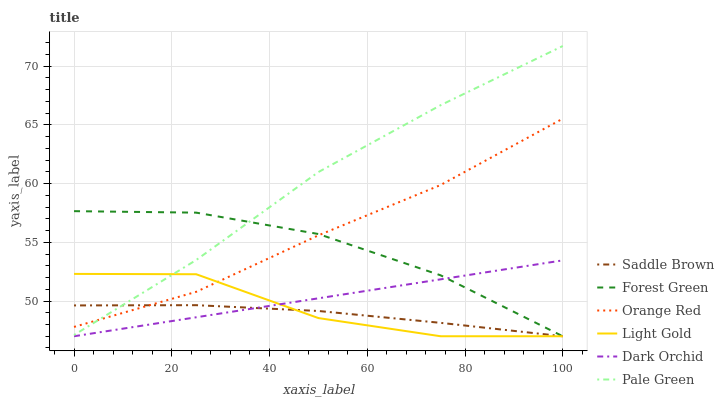Does Saddle Brown have the minimum area under the curve?
Answer yes or no. Yes. Does Pale Green have the maximum area under the curve?
Answer yes or no. Yes. Does Orange Red have the minimum area under the curve?
Answer yes or no. No. Does Orange Red have the maximum area under the curve?
Answer yes or no. No. Is Dark Orchid the smoothest?
Answer yes or no. Yes. Is Light Gold the roughest?
Answer yes or no. Yes. Is Orange Red the smoothest?
Answer yes or no. No. Is Orange Red the roughest?
Answer yes or no. No. Does Dark Orchid have the lowest value?
Answer yes or no. Yes. Does Orange Red have the lowest value?
Answer yes or no. No. Does Pale Green have the highest value?
Answer yes or no. Yes. Does Orange Red have the highest value?
Answer yes or no. No. Is Dark Orchid less than Orange Red?
Answer yes or no. Yes. Is Pale Green greater than Dark Orchid?
Answer yes or no. Yes. Does Light Gold intersect Saddle Brown?
Answer yes or no. Yes. Is Light Gold less than Saddle Brown?
Answer yes or no. No. Is Light Gold greater than Saddle Brown?
Answer yes or no. No. Does Dark Orchid intersect Orange Red?
Answer yes or no. No. 